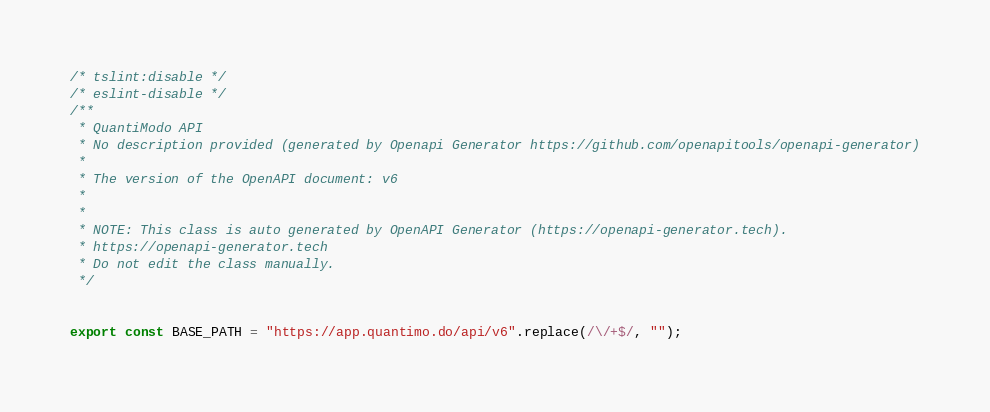<code> <loc_0><loc_0><loc_500><loc_500><_TypeScript_>/* tslint:disable */
/* eslint-disable */
/**
 * QuantiModo API
 * No description provided (generated by Openapi Generator https://github.com/openapitools/openapi-generator)
 *
 * The version of the OpenAPI document: v6
 * 
 *
 * NOTE: This class is auto generated by OpenAPI Generator (https://openapi-generator.tech).
 * https://openapi-generator.tech
 * Do not edit the class manually.
 */


export const BASE_PATH = "https://app.quantimo.do/api/v6".replace(/\/+$/, "");
</code> 